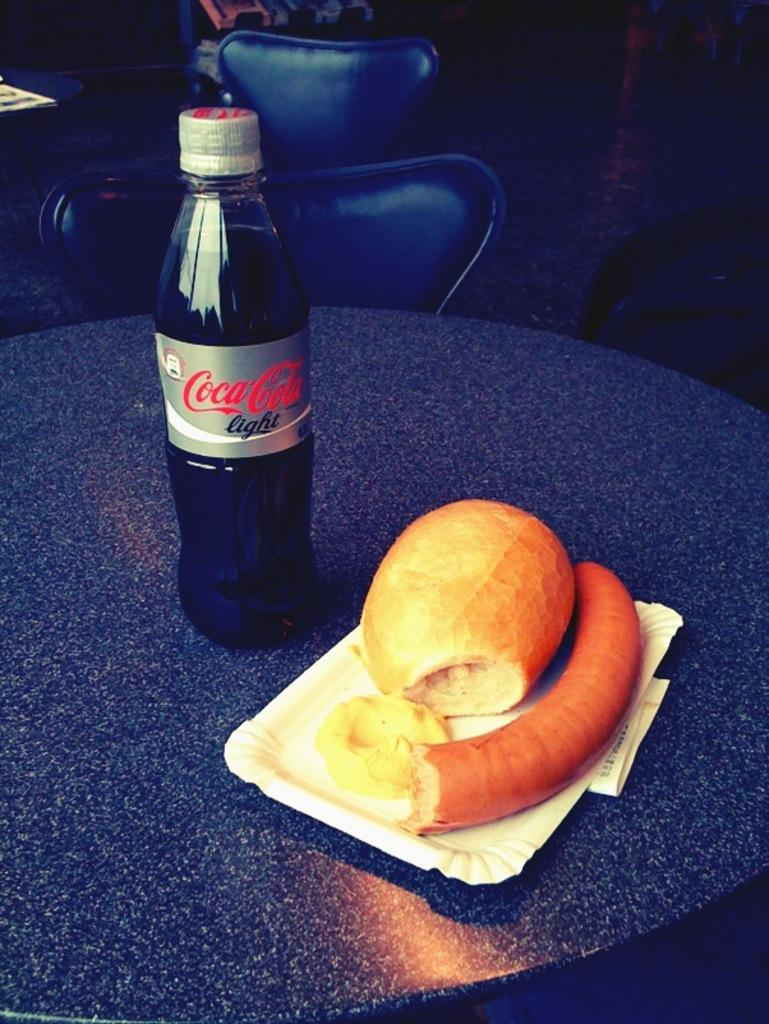What object is on the table with a tail-like feature? There is a tail on the table. What else can be found on the table? There is a bottle and a plate on the table. What is on the plate? There are food items on the table. What is located behind the table? There are chairs behind the table. How many boys are playing with the spade in the image? There are no boys or spades present in the image. 